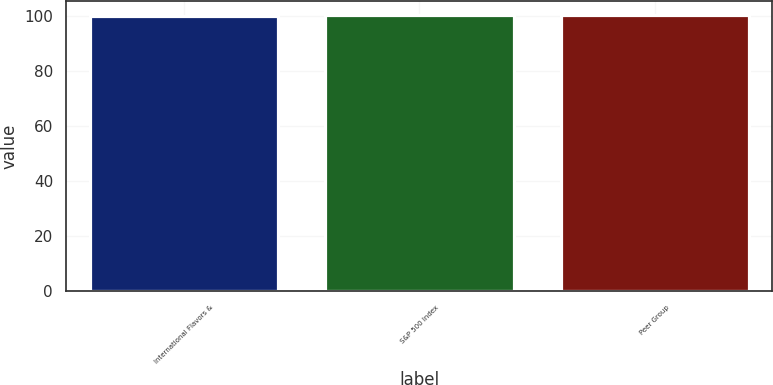<chart> <loc_0><loc_0><loc_500><loc_500><bar_chart><fcel>International Flavors &<fcel>S&P 500 Index<fcel>Peer Group<nl><fcel>100<fcel>100.1<fcel>100.2<nl></chart> 